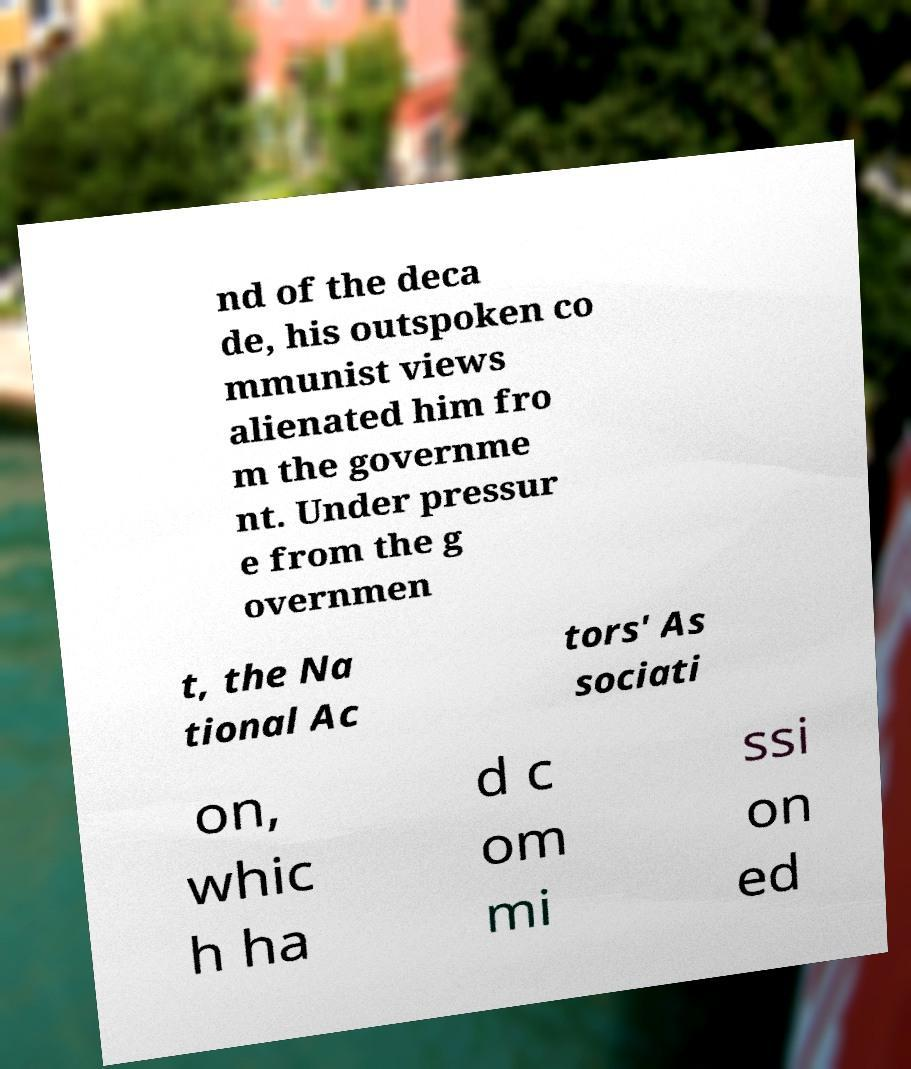Could you assist in decoding the text presented in this image and type it out clearly? nd of the deca de, his outspoken co mmunist views alienated him fro m the governme nt. Under pressur e from the g overnmen t, the Na tional Ac tors' As sociati on, whic h ha d c om mi ssi on ed 